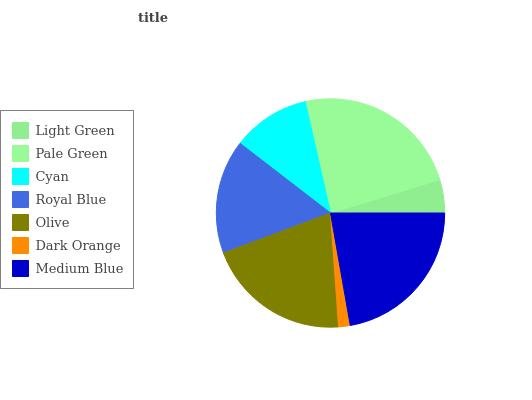Is Dark Orange the minimum?
Answer yes or no. Yes. Is Pale Green the maximum?
Answer yes or no. Yes. Is Cyan the minimum?
Answer yes or no. No. Is Cyan the maximum?
Answer yes or no. No. Is Pale Green greater than Cyan?
Answer yes or no. Yes. Is Cyan less than Pale Green?
Answer yes or no. Yes. Is Cyan greater than Pale Green?
Answer yes or no. No. Is Pale Green less than Cyan?
Answer yes or no. No. Is Royal Blue the high median?
Answer yes or no. Yes. Is Royal Blue the low median?
Answer yes or no. Yes. Is Dark Orange the high median?
Answer yes or no. No. Is Medium Blue the low median?
Answer yes or no. No. 